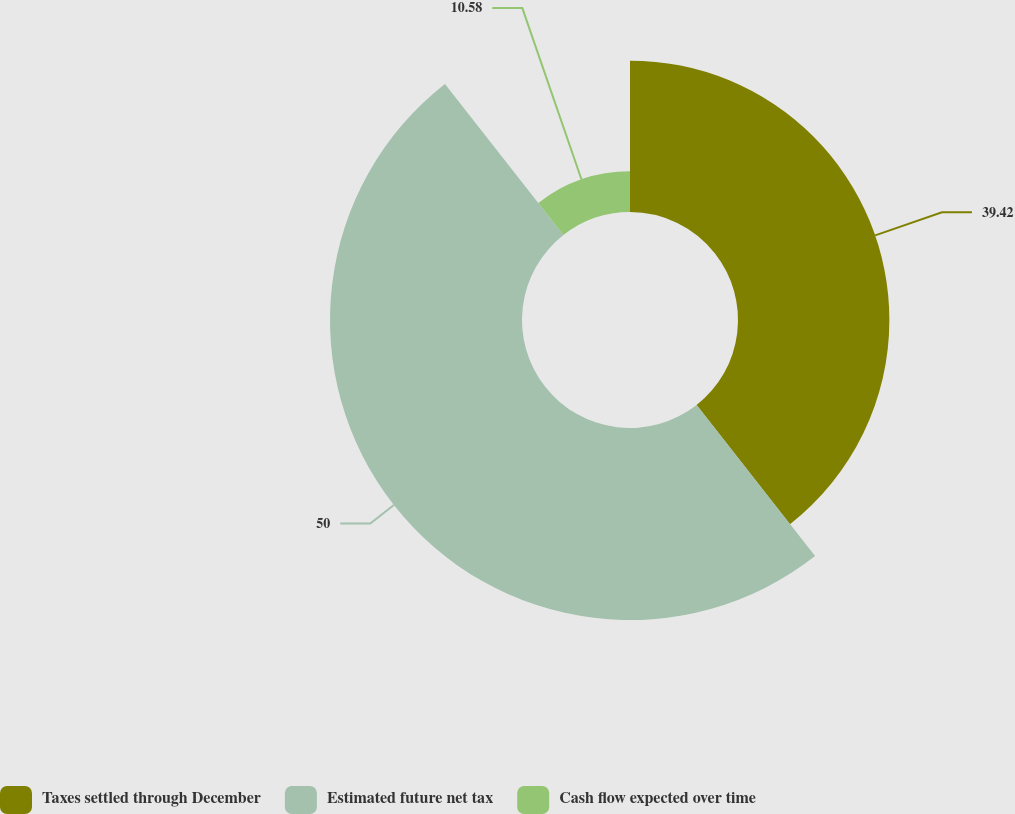<chart> <loc_0><loc_0><loc_500><loc_500><pie_chart><fcel>Taxes settled through December<fcel>Estimated future net tax<fcel>Cash flow expected over time<nl><fcel>39.42%<fcel>50.0%<fcel>10.58%<nl></chart> 